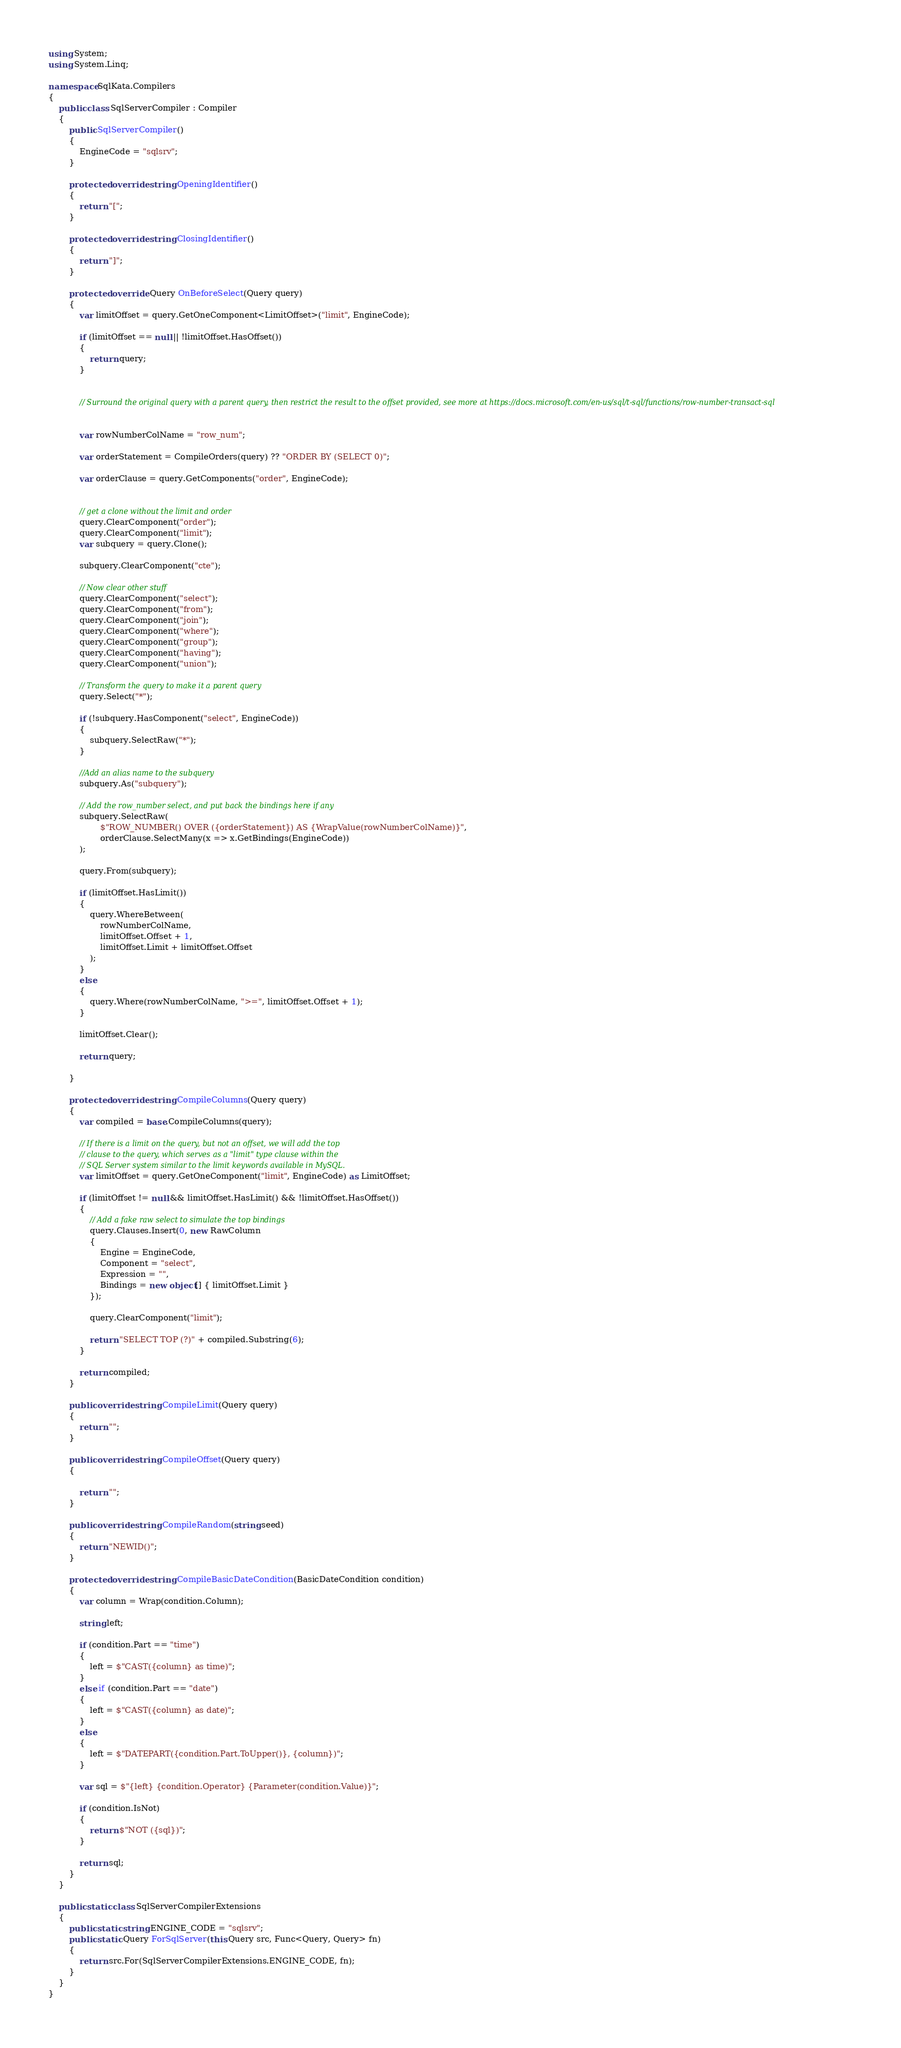Convert code to text. <code><loc_0><loc_0><loc_500><loc_500><_C#_>using System;
using System.Linq;

namespace SqlKata.Compilers
{
    public class SqlServerCompiler : Compiler
    {
        public SqlServerCompiler()
        {
            EngineCode = "sqlsrv";
        }

        protected override string OpeningIdentifier()
        {
            return "[";
        }

        protected override string ClosingIdentifier()
        {
            return "]";
        }

        protected override Query OnBeforeSelect(Query query)
        {
            var limitOffset = query.GetOneComponent<LimitOffset>("limit", EngineCode);

            if (limitOffset == null || !limitOffset.HasOffset())
            {
                return query;
            }


            // Surround the original query with a parent query, then restrict the result to the offset provided, see more at https://docs.microsoft.com/en-us/sql/t-sql/functions/row-number-transact-sql


            var rowNumberColName = "row_num";

            var orderStatement = CompileOrders(query) ?? "ORDER BY (SELECT 0)";

            var orderClause = query.GetComponents("order", EngineCode);


            // get a clone without the limit and order
            query.ClearComponent("order");
            query.ClearComponent("limit");
            var subquery = query.Clone();

            subquery.ClearComponent("cte");

            // Now clear other stuff
            query.ClearComponent("select");
            query.ClearComponent("from");
            query.ClearComponent("join");
            query.ClearComponent("where");
            query.ClearComponent("group");
            query.ClearComponent("having");
            query.ClearComponent("union");

            // Transform the query to make it a parent query
            query.Select("*");

            if (!subquery.HasComponent("select", EngineCode))
            {
                subquery.SelectRaw("*");
            }

            //Add an alias name to the subquery
            subquery.As("subquery");

            // Add the row_number select, and put back the bindings here if any
            subquery.SelectRaw(
                    $"ROW_NUMBER() OVER ({orderStatement}) AS {WrapValue(rowNumberColName)}",
                    orderClause.SelectMany(x => x.GetBindings(EngineCode))
            );

            query.From(subquery);

            if (limitOffset.HasLimit())
            {
                query.WhereBetween(
                    rowNumberColName,
                    limitOffset.Offset + 1,
                    limitOffset.Limit + limitOffset.Offset
                );
            }
            else
            {
                query.Where(rowNumberColName, ">=", limitOffset.Offset + 1);
            }

            limitOffset.Clear();

            return query;

        }

        protected override string CompileColumns(Query query)
        {
            var compiled = base.CompileColumns(query);

            // If there is a limit on the query, but not an offset, we will add the top
            // clause to the query, which serves as a "limit" type clause within the
            // SQL Server system similar to the limit keywords available in MySQL.
            var limitOffset = query.GetOneComponent("limit", EngineCode) as LimitOffset;

            if (limitOffset != null && limitOffset.HasLimit() && !limitOffset.HasOffset())
            {
                // Add a fake raw select to simulate the top bindings
                query.Clauses.Insert(0, new RawColumn
                {
                    Engine = EngineCode,
                    Component = "select",
                    Expression = "",
                    Bindings = new object[] { limitOffset.Limit }
                });

                query.ClearComponent("limit");

                return "SELECT TOP (?)" + compiled.Substring(6);
            }

            return compiled;
        }

        public override string CompileLimit(Query query)
        {
            return "";
        }

        public override string CompileOffset(Query query)
        {

            return "";
        }

        public override string CompileRandom(string seed)
        {
            return "NEWID()";
        }

        protected override string CompileBasicDateCondition(BasicDateCondition condition)
        {
            var column = Wrap(condition.Column);

            string left;

            if (condition.Part == "time")
            {
                left = $"CAST({column} as time)";
            }
            else if (condition.Part == "date")
            {
                left = $"CAST({column} as date)";
            }
            else
            {
                left = $"DATEPART({condition.Part.ToUpper()}, {column})";
            }

            var sql = $"{left} {condition.Operator} {Parameter(condition.Value)}";

            if (condition.IsNot)
            {
                return $"NOT ({sql})";
            }

            return sql;
        }
    }

    public static class SqlServerCompilerExtensions
    {
        public static string ENGINE_CODE = "sqlsrv";
        public static Query ForSqlServer(this Query src, Func<Query, Query> fn)
        {
            return src.For(SqlServerCompilerExtensions.ENGINE_CODE, fn);
        }
    }
}
</code> 